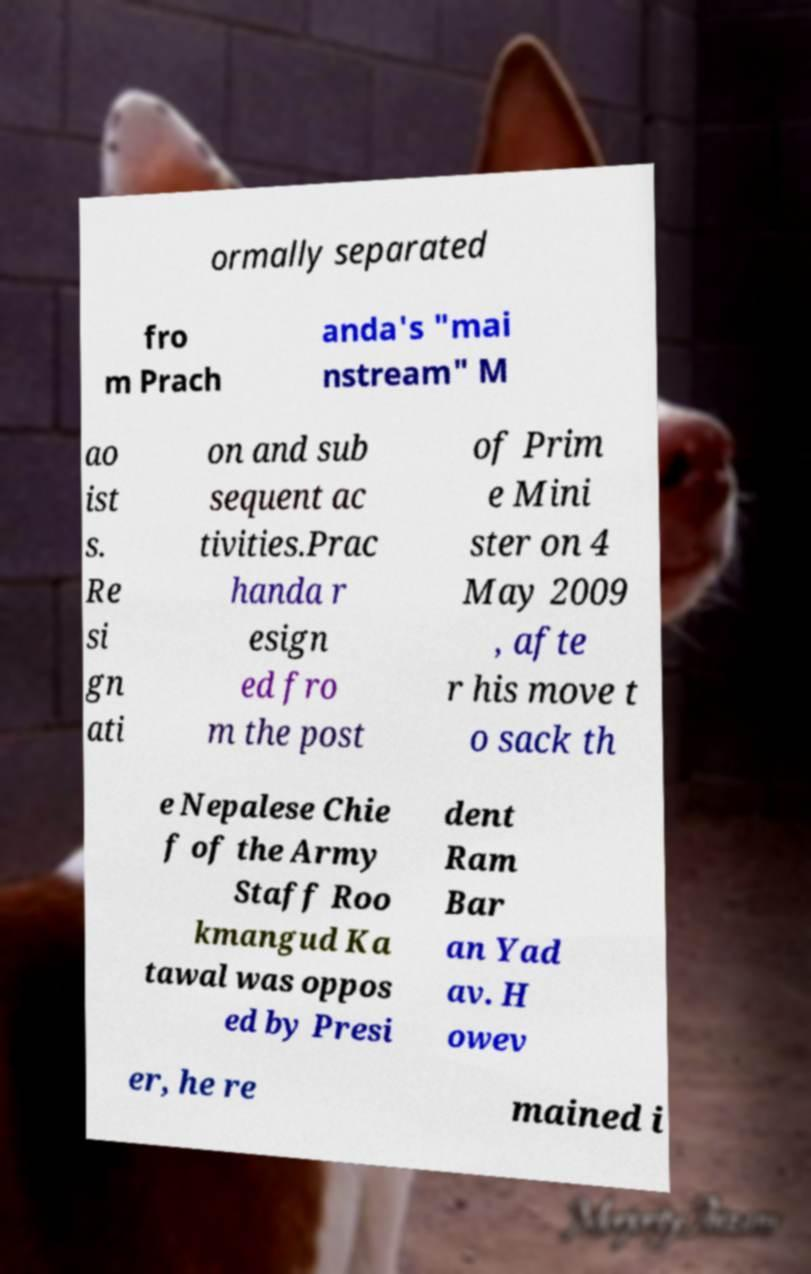Please identify and transcribe the text found in this image. ormally separated fro m Prach anda's "mai nstream" M ao ist s. Re si gn ati on and sub sequent ac tivities.Prac handa r esign ed fro m the post of Prim e Mini ster on 4 May 2009 , afte r his move t o sack th e Nepalese Chie f of the Army Staff Roo kmangud Ka tawal was oppos ed by Presi dent Ram Bar an Yad av. H owev er, he re mained i 